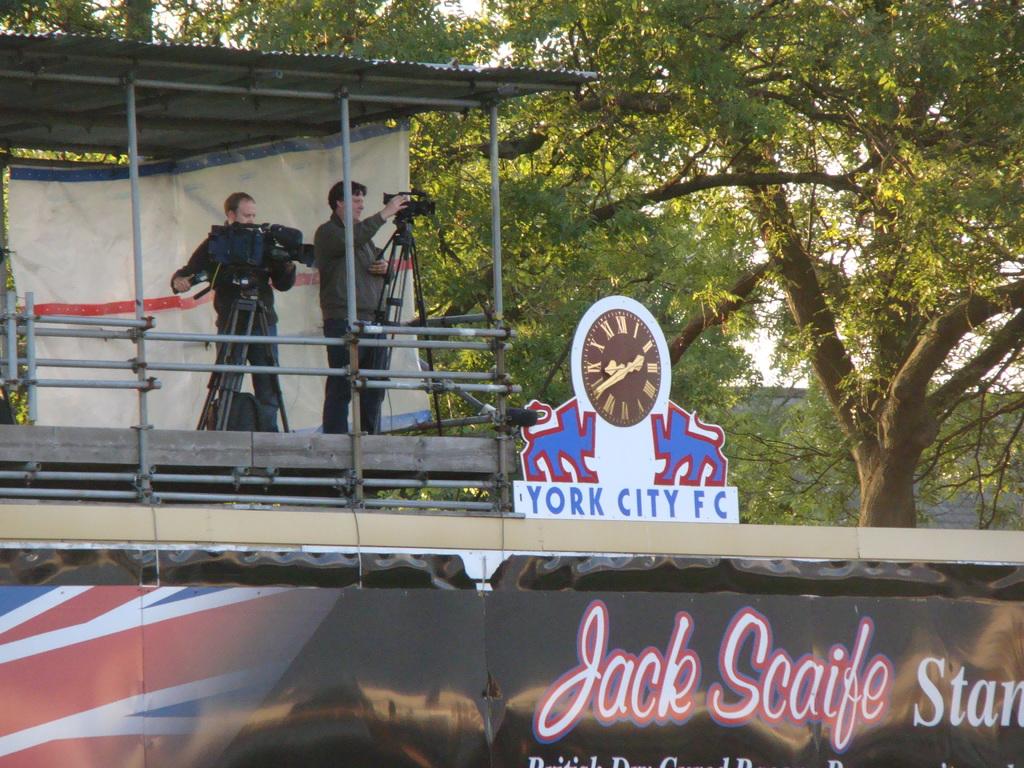What is the name of the team on the clock?
Provide a succinct answer. York city fc. 